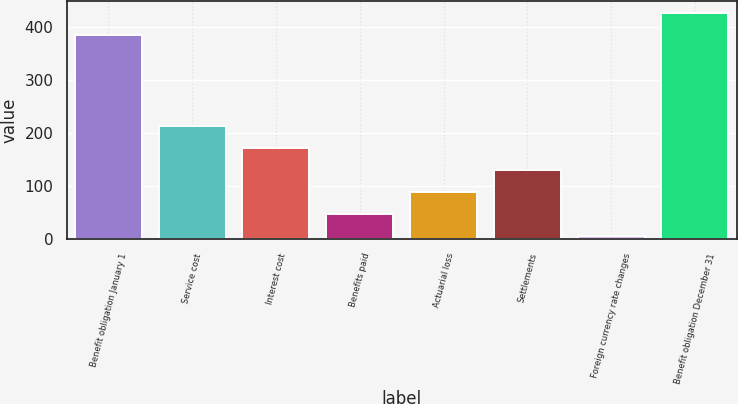<chart> <loc_0><loc_0><loc_500><loc_500><bar_chart><fcel>Benefit obligation January 1<fcel>Service cost<fcel>Interest cost<fcel>Benefits paid<fcel>Actuarial loss<fcel>Settlements<fcel>Foreign currency rate changes<fcel>Benefit obligation December 31<nl><fcel>385<fcel>213<fcel>171.4<fcel>46.6<fcel>88.2<fcel>129.8<fcel>5<fcel>426.6<nl></chart> 